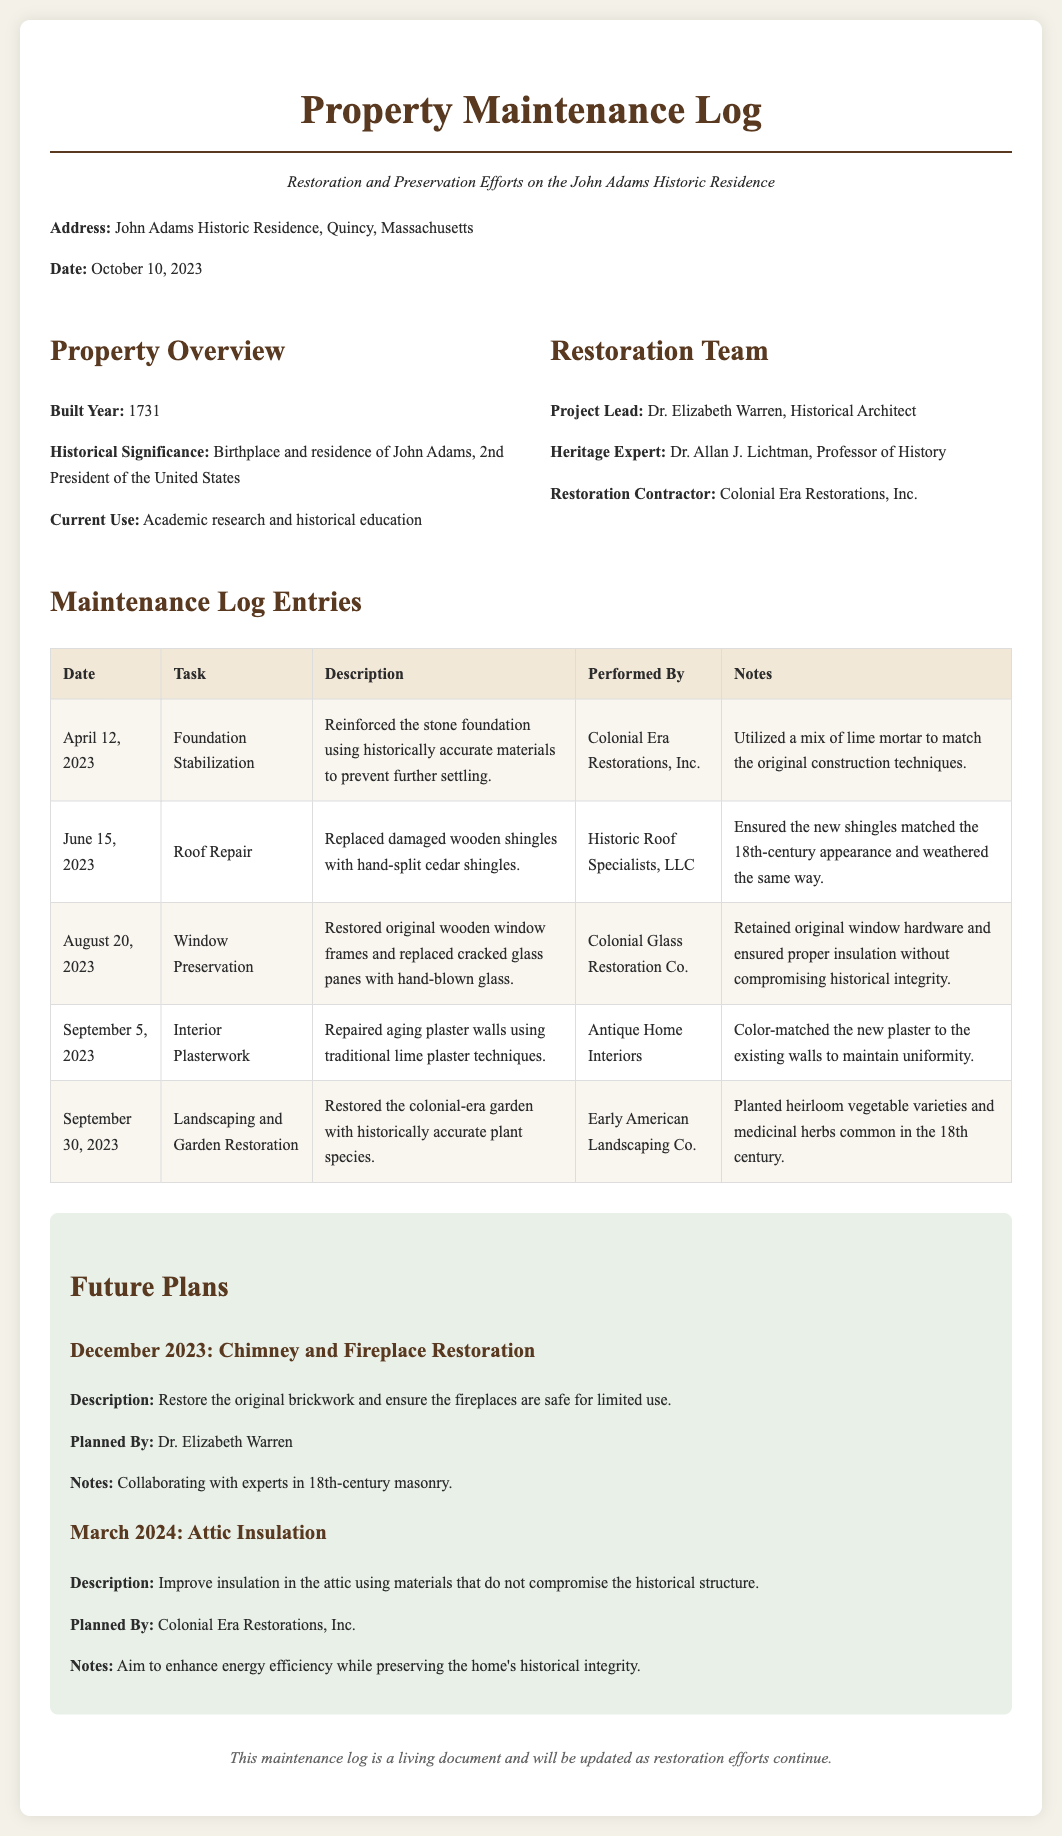What is the address of the property? The address is provided in the introduction of the document under the Property Overview section.
Answer: John Adams Historic Residence, Quincy, Massachusetts Who is the Project Lead for the restoration? The Project Lead is mentioned in the Restoration Team section.
Answer: Dr. Elizabeth Warren When was the Foundation Stabilization task performed? The date is listed in the Maintenance Log Entries table for the Foundation Stabilization task.
Answer: April 12, 2023 What was restored during the August 20, 2023 entry? The description in the Maintenance Log Entries table specifies the task performed on that date.
Answer: Window Preservation In what year was the historic residence built? The year of construction is indicated in the Property Overview section of the document.
Answer: 1731 What is the planned task for December 2023? This information is found in the Future Plans section detailing upcoming maintenance activities.
Answer: Chimney and Fireplace Restoration What type of shingles were replaced during the Roof Repair? The specific details about the replacement materials are given in the Maintenance Log Entries table.
Answer: Hand-split cedar shingles How many maintenance log entries are recorded in this document? The number of entries can be counted based on the Maintenance Log Entries table.
Answer: Five 